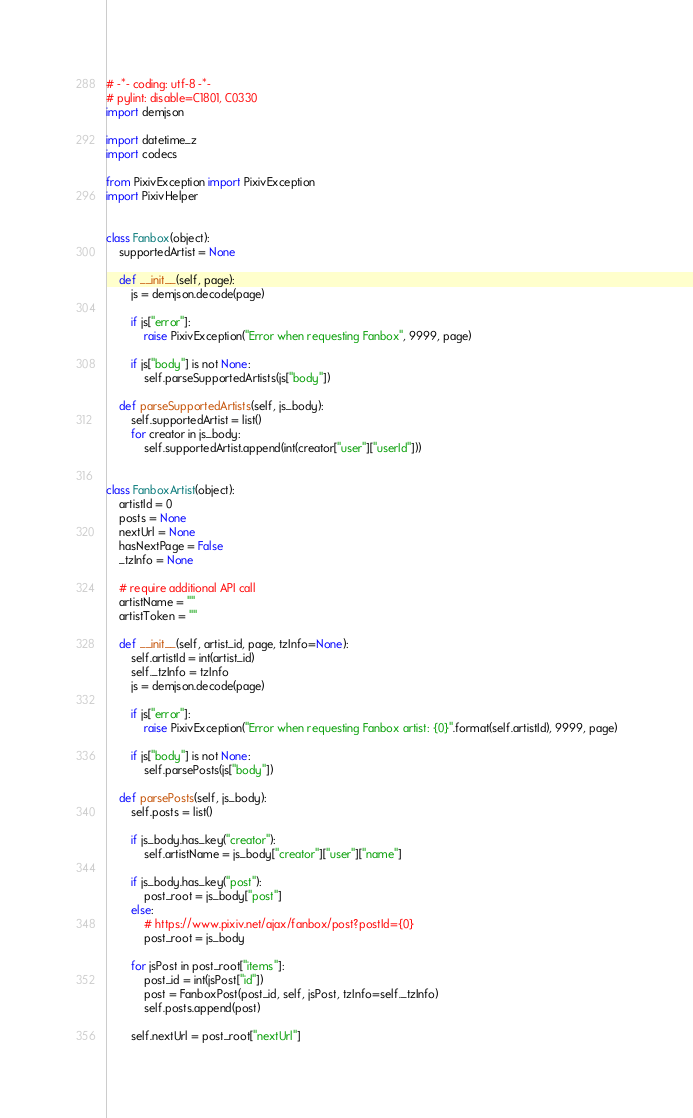Convert code to text. <code><loc_0><loc_0><loc_500><loc_500><_Python_># -*- coding: utf-8 -*-
# pylint: disable=C1801, C0330
import demjson

import datetime_z
import codecs

from PixivException import PixivException
import PixivHelper


class Fanbox(object):
    supportedArtist = None

    def __init__(self, page):
        js = demjson.decode(page)

        if js["error"]:
            raise PixivException("Error when requesting Fanbox", 9999, page)

        if js["body"] is not None:
            self.parseSupportedArtists(js["body"])

    def parseSupportedArtists(self, js_body):
        self.supportedArtist = list()
        for creator in js_body:
            self.supportedArtist.append(int(creator["user"]["userId"]))


class FanboxArtist(object):
    artistId = 0
    posts = None
    nextUrl = None
    hasNextPage = False
    _tzInfo = None

    # require additional API call
    artistName = ""
    artistToken = ""

    def __init__(self, artist_id, page, tzInfo=None):
        self.artistId = int(artist_id)
        self._tzInfo = tzInfo
        js = demjson.decode(page)

        if js["error"]:
            raise PixivException("Error when requesting Fanbox artist: {0}".format(self.artistId), 9999, page)

        if js["body"] is not None:
            self.parsePosts(js["body"])

    def parsePosts(self, js_body):
        self.posts = list()

        if js_body.has_key("creator"):
            self.artistName = js_body["creator"]["user"]["name"]

        if js_body.has_key("post"):
            post_root = js_body["post"]
        else:
            # https://www.pixiv.net/ajax/fanbox/post?postId={0}
            post_root = js_body

        for jsPost in post_root["items"]:
            post_id = int(jsPost["id"])
            post = FanboxPost(post_id, self, jsPost, tzInfo=self._tzInfo)
            self.posts.append(post)

        self.nextUrl = post_root["nextUrl"]</code> 